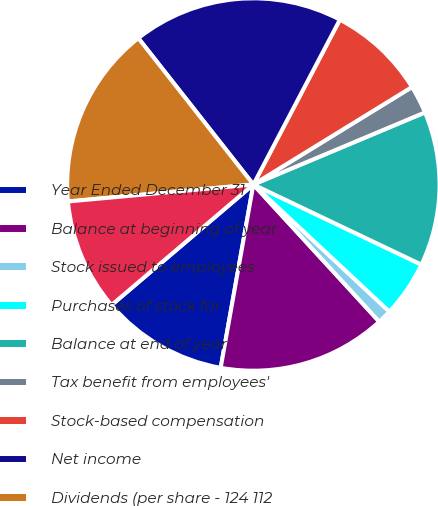Convert chart to OTSL. <chart><loc_0><loc_0><loc_500><loc_500><pie_chart><fcel>Year Ended December 31<fcel>Balance at beginning of year<fcel>Stock issued to employees<fcel>Purchases of stock for<fcel>Balance at end of year<fcel>Tax benefit from employees'<fcel>Stock-based compensation<fcel>Net income<fcel>Dividends (per share - 124 112<fcel>Net foreign currency<nl><fcel>10.98%<fcel>14.63%<fcel>1.22%<fcel>4.88%<fcel>13.41%<fcel>2.44%<fcel>8.54%<fcel>18.29%<fcel>15.85%<fcel>9.76%<nl></chart> 